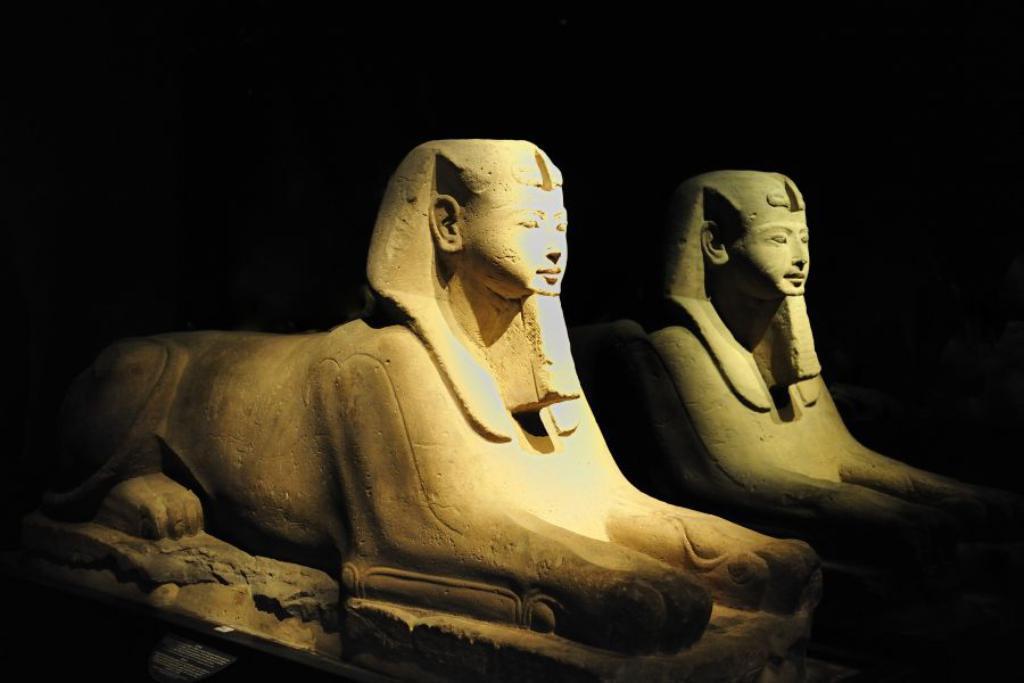How would you summarize this image in a sentence or two? In this image we can see statues. There is a dark background. 